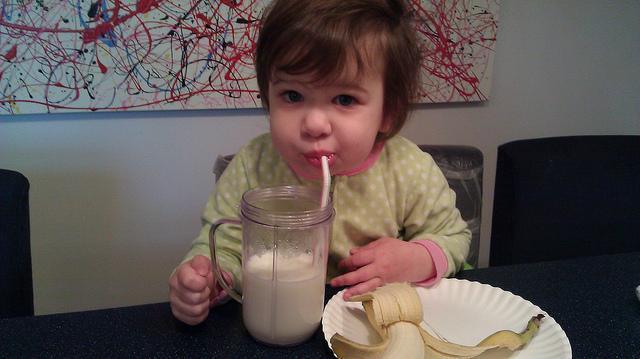How many kids are there?
Give a very brief answer. 1. How many chairs can be seen?
Give a very brief answer. 3. 